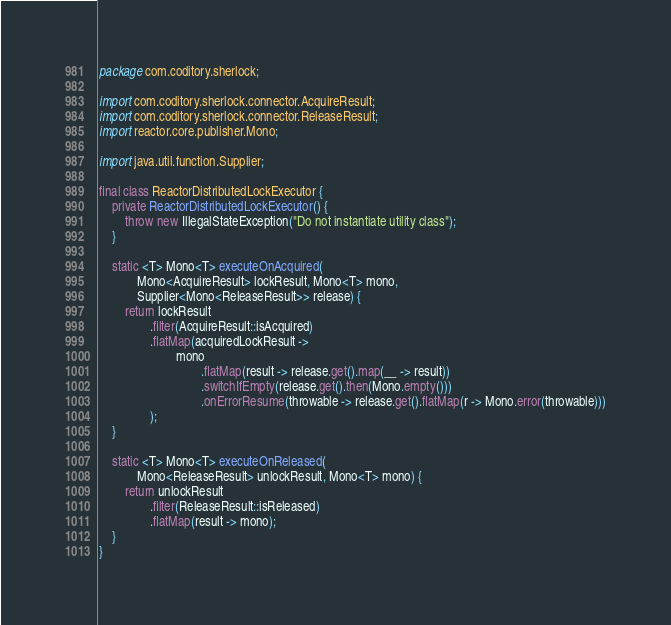Convert code to text. <code><loc_0><loc_0><loc_500><loc_500><_Java_>package com.coditory.sherlock;

import com.coditory.sherlock.connector.AcquireResult;
import com.coditory.sherlock.connector.ReleaseResult;
import reactor.core.publisher.Mono;

import java.util.function.Supplier;

final class ReactorDistributedLockExecutor {
    private ReactorDistributedLockExecutor() {
        throw new IllegalStateException("Do not instantiate utility class");
    }

    static <T> Mono<T> executeOnAcquired(
            Mono<AcquireResult> lockResult, Mono<T> mono,
            Supplier<Mono<ReleaseResult>> release) {
        return lockResult
                .filter(AcquireResult::isAcquired)
                .flatMap(acquiredLockResult ->
                        mono
                                .flatMap(result -> release.get().map(__ -> result))
                                .switchIfEmpty(release.get().then(Mono.empty()))
                                .onErrorResume(throwable -> release.get().flatMap(r -> Mono.error(throwable)))
                );
    }

    static <T> Mono<T> executeOnReleased(
            Mono<ReleaseResult> unlockResult, Mono<T> mono) {
        return unlockResult
                .filter(ReleaseResult::isReleased)
                .flatMap(result -> mono);
    }
}
</code> 